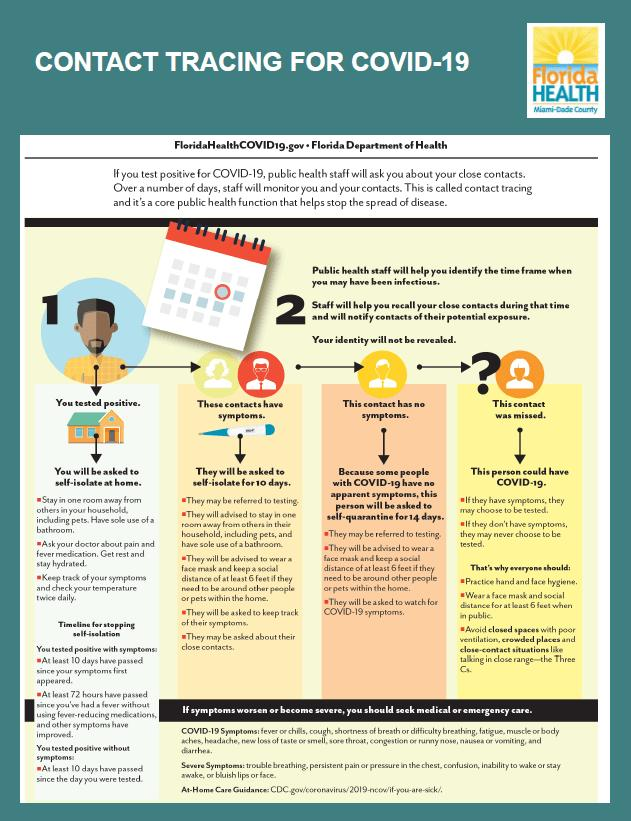Identify some key points in this picture. If a person tests positive for the new coronavirus, they will be asked to self-isolate at home. If a COVID-positive individual has no symptoms, they are advised to self-quarantine for a period of 14 days in accordance with the guidelines set forth by public health authorities. If a COVID-positive individual's contacts exhibit symptoms, they will be required to self-isolate for a period of ten days as a preventative measure. 